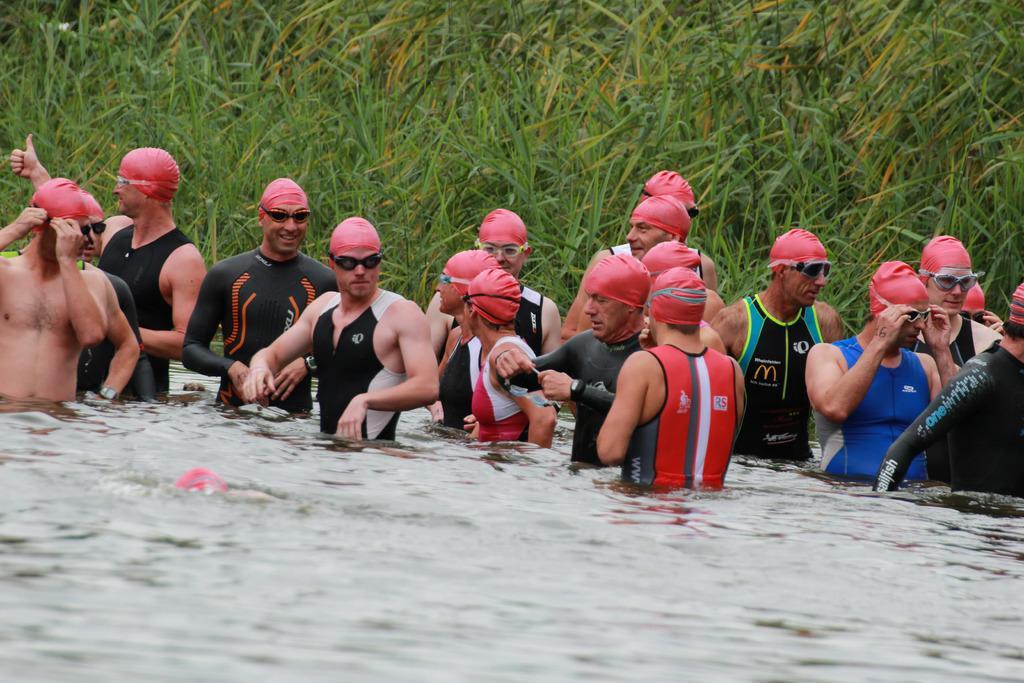Can you describe this image briefly? In the image we can see there are people standing in the water and they are wearing swimming cap and goggles. Behind there are plants. 